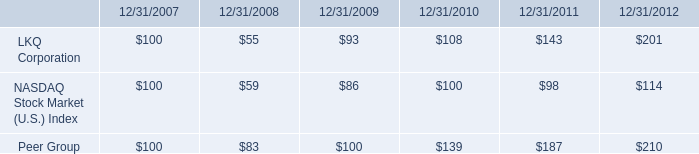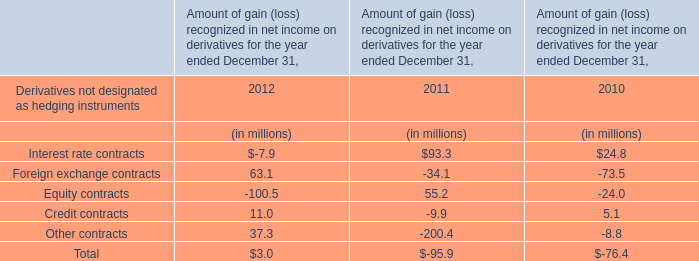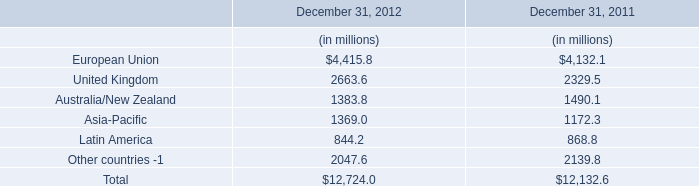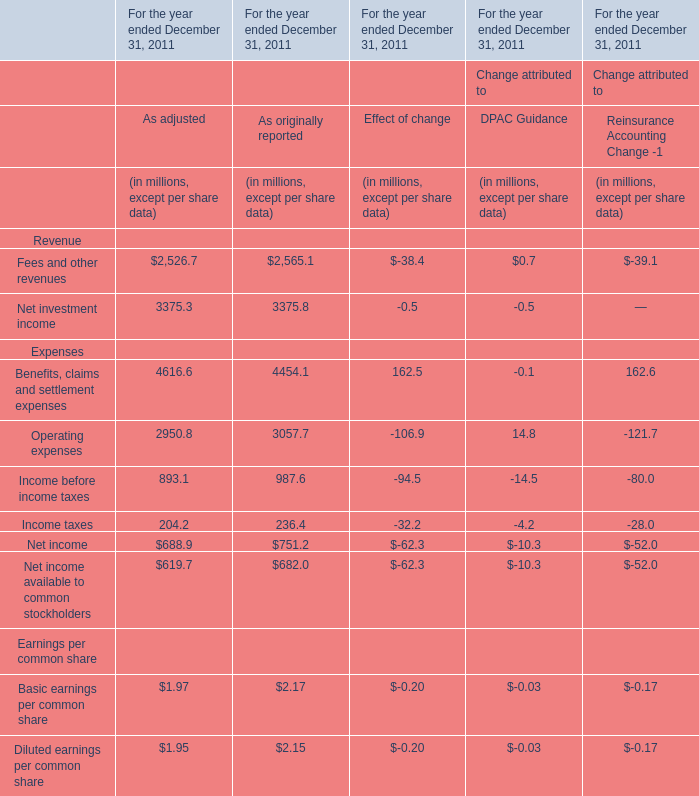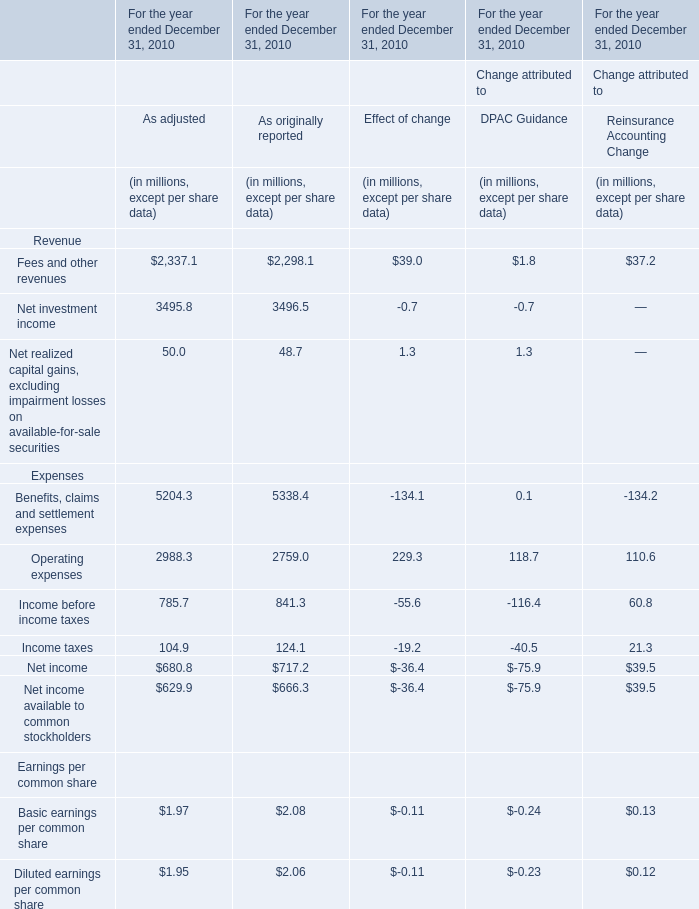In the section with largest amount of Fees and other revenues, what's the sum of Expenses? (in million) 
Computations: (5204.3 + 2988.3)
Answer: 8192.6. 